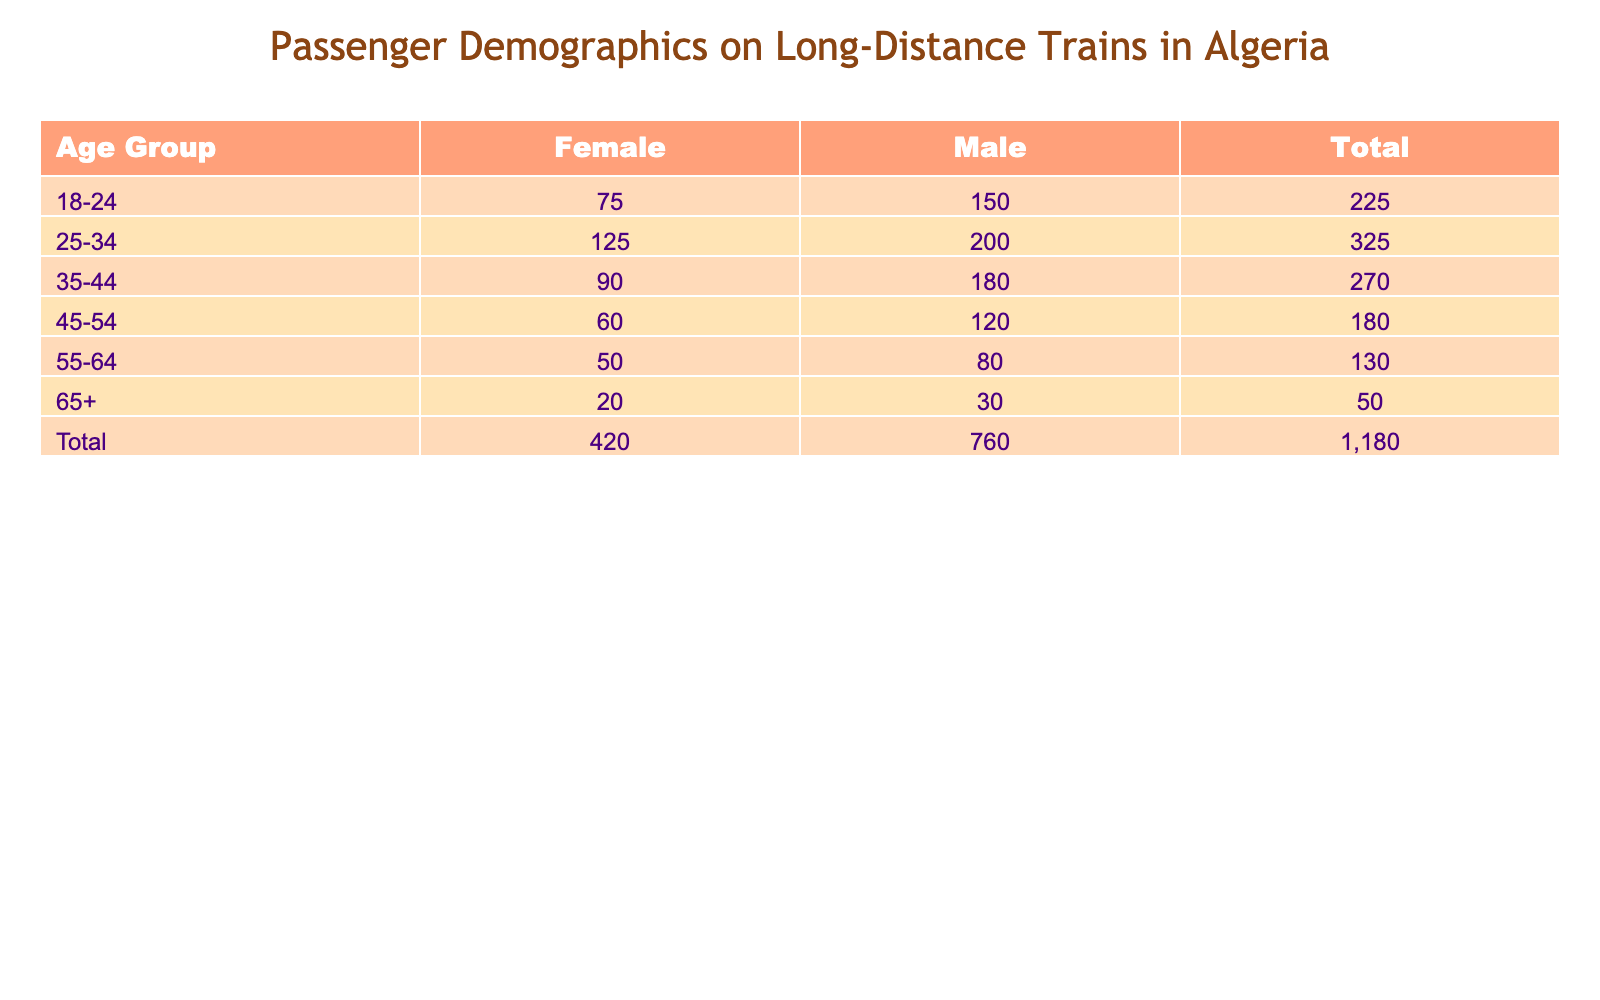What is the total number of male passengers in the 25-34 age group? Looking at the row for the 25-34 age group, the count for male passengers is given as 200. Therefore, the total number of male passengers in this age group is simply that value.
Answer: 200 What is the total count of female passengers across all age groups? To find the total count of female passengers, we need to sum up the counts for female passengers in each age group: 75 (18-24) + 125 (25-34) + 90 (35-44) + 60 (45-54) + 50 (55-64) + 20 (65+) = 70 + 125 + 90 + 60 + 50 + 20 = 470.
Answer: 470 Is there a higher number of male passengers in the 35-44 age group than in the 45-54 age group? The count for male passengers in the 35-44 age group is 180, while in the 45-54 age group, it is 120. Since 180 is greater than 120, the statement is true.
Answer: Yes What is the difference in the number of male and female passengers in the 18-24 age group? In the 18-24 age group, there are 150 male passengers and 75 female passengers. To find the difference, we subtract the number of female passengers from the number of male passengers: 150 - 75 = 75.
Answer: 75 What is the average number of passengers for each gender across all age groups? For males, we sum the counts: 150 + 200 + 180 + 120 + 80 + 30 = 760. There are 6 groups, so the average for males is 760/6 = approximately 126.67. For females, we sum the counts: 75 + 125 + 90 + 60 + 50 + 20 = 420. The average for females is 420/6 = 70. Thus, the average for males is about 126.67 and for females is 70.
Answer: Males: 126.67, Females: 70 In which age group do female passengers have the lowest count? By checking the count of female passengers across all age groups: 75 (18-24), 125 (25-34), 90 (35-44), 60 (45-54), 50 (55-64), 20 (65+), we see that the lowest count is 20, which corresponds to the 65+ age group.
Answer: 65+ How many more male passengers are there in the 25-34 age group compared to the 55-64 age group? In the 25-34 age group, there are 200 male passengers, while in the 55-64 age group, there are 80 male passengers. The difference is calculated as: 200 - 80 = 120.
Answer: 120 Is the total number of passengers aged 45-54 greater than the total number of passengers aged 18-24? First, we find the total for the 45-54 age group: 120 (male) + 60 (female) = 180. For the 18-24 age group, the total is 150 (male) + 75 (female) = 225. Since 180 is not greater than 225, the answer is no.
Answer: No 